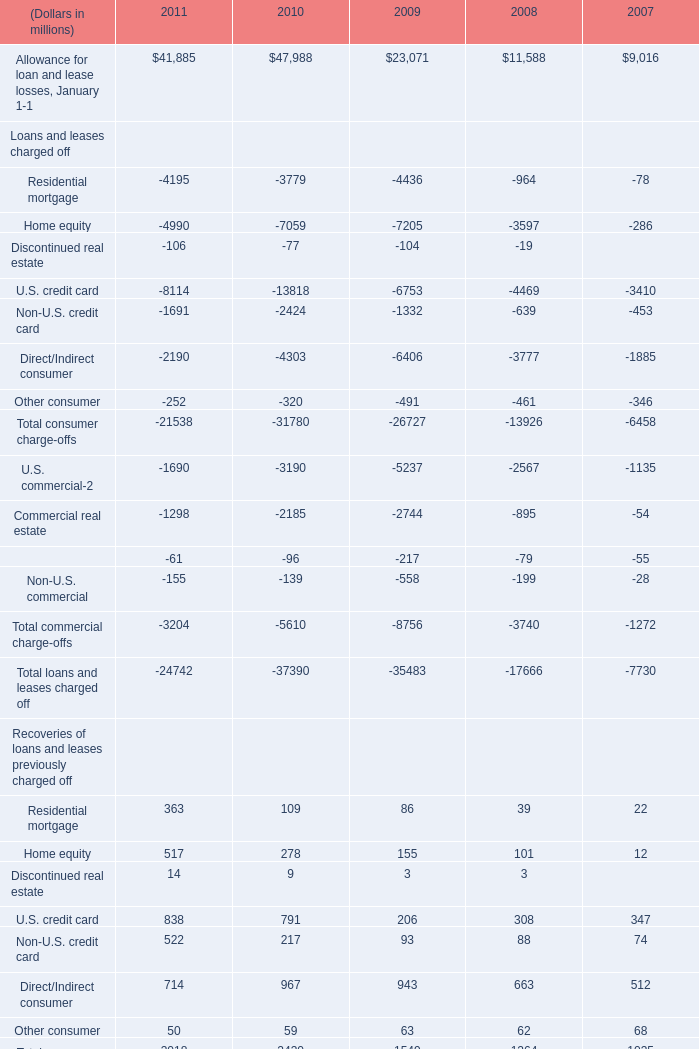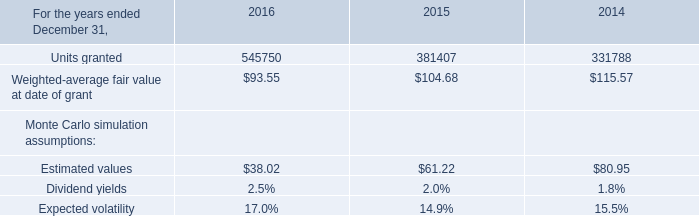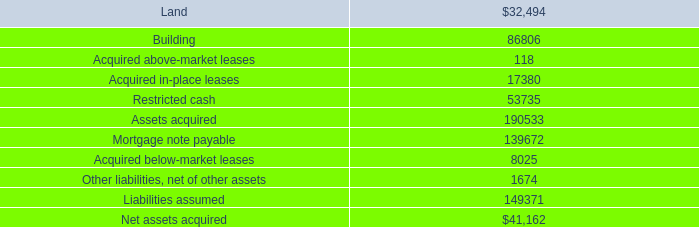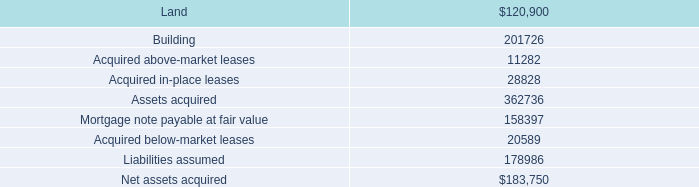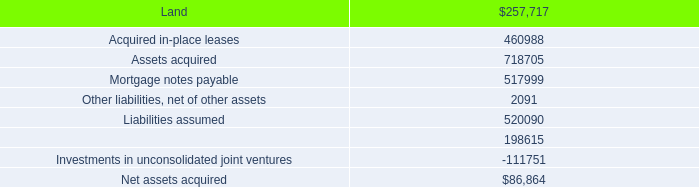What's the average of Residential mortgage and Home equity and Discontinued real estate in 2011? (in millions) 
Computations: ((363 + 517) + 14)
Answer: 894.0. 